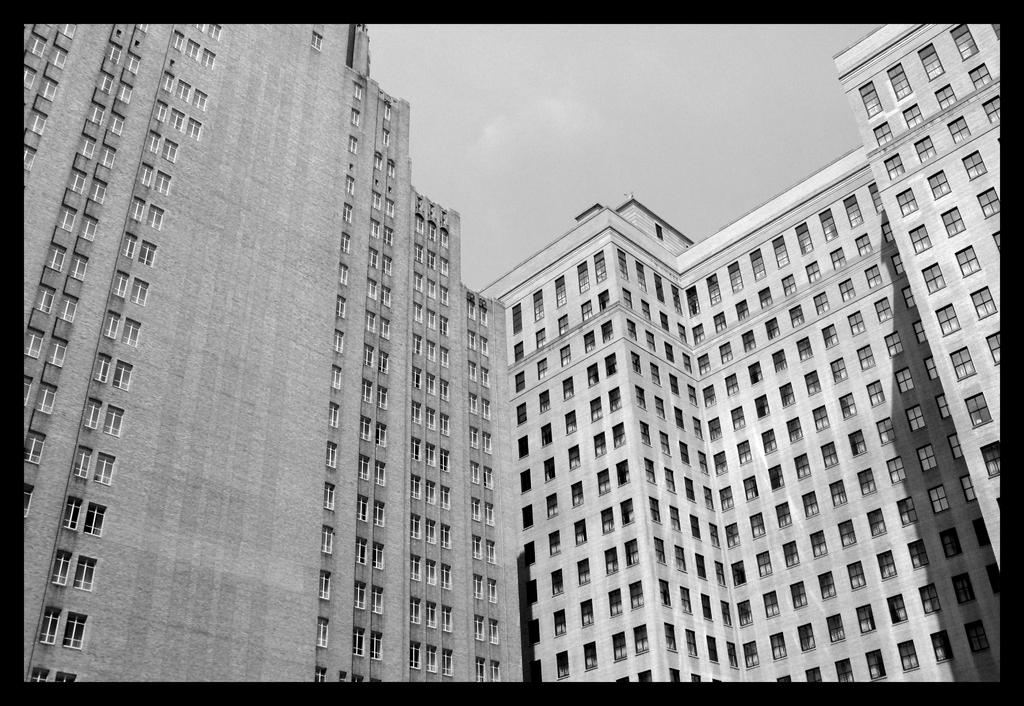How has the image been altered? The image is edited and black and white. What structures are present in the image? There are two tall buildings in the image. What feature is prominent in the buildings? There are a lot of windows visible in the buildings. Can you see any friends playing with a wren in the image? There are no friends or wrens present in the image; it features two tall buildings with many windows. Is there a man standing in front of the buildings in the image? There is no man visible in the image; it only shows two tall buildings with many windows. 